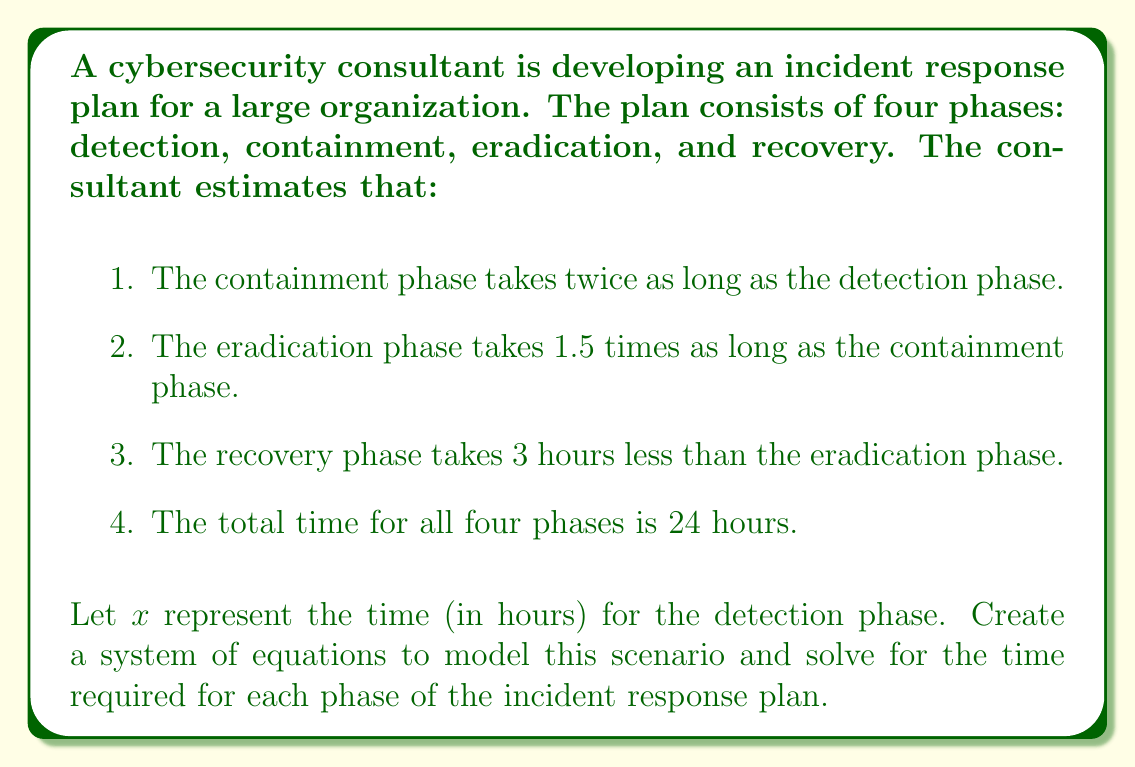Teach me how to tackle this problem. Let's approach this problem step by step:

1. Define variables:
   $x$ = time for detection phase (given)
   $y$ = time for containment phase
   $z$ = time for eradication phase
   $w$ = time for recovery phase

2. Create equations based on the given information:
   a. $y = 2x$ (containment takes twice as long as detection)
   b. $z = 1.5y$ (eradication takes 1.5 times as long as containment)
   c. $w = z - 3$ (recovery takes 3 hours less than eradication)
   d. $x + y + z + w = 24$ (total time for all phases is 24 hours)

3. Substitute equations into the total time equation:
   $x + 2x + 1.5(2x) + (1.5(2x) - 3) = 24$

4. Simplify:
   $x + 2x + 3x + 3x - 3 = 24$
   $9x - 3 = 24$

5. Solve for $x$:
   $9x = 27$
   $x = 3$

6. Calculate times for other phases:
   Detection (x): 3 hours
   Containment (y): $y = 2x = 2(3) = 6$ hours
   Eradication (z): $z = 1.5y = 1.5(6) = 9$ hours
   Recovery (w): $w = z - 3 = 9 - 3 = 6$ hours

7. Verify the total time:
   $3 + 6 + 9 + 6 = 24$ hours
Answer: Detection phase: 3 hours
Containment phase: 6 hours
Eradication phase: 9 hours
Recovery phase: 6 hours 